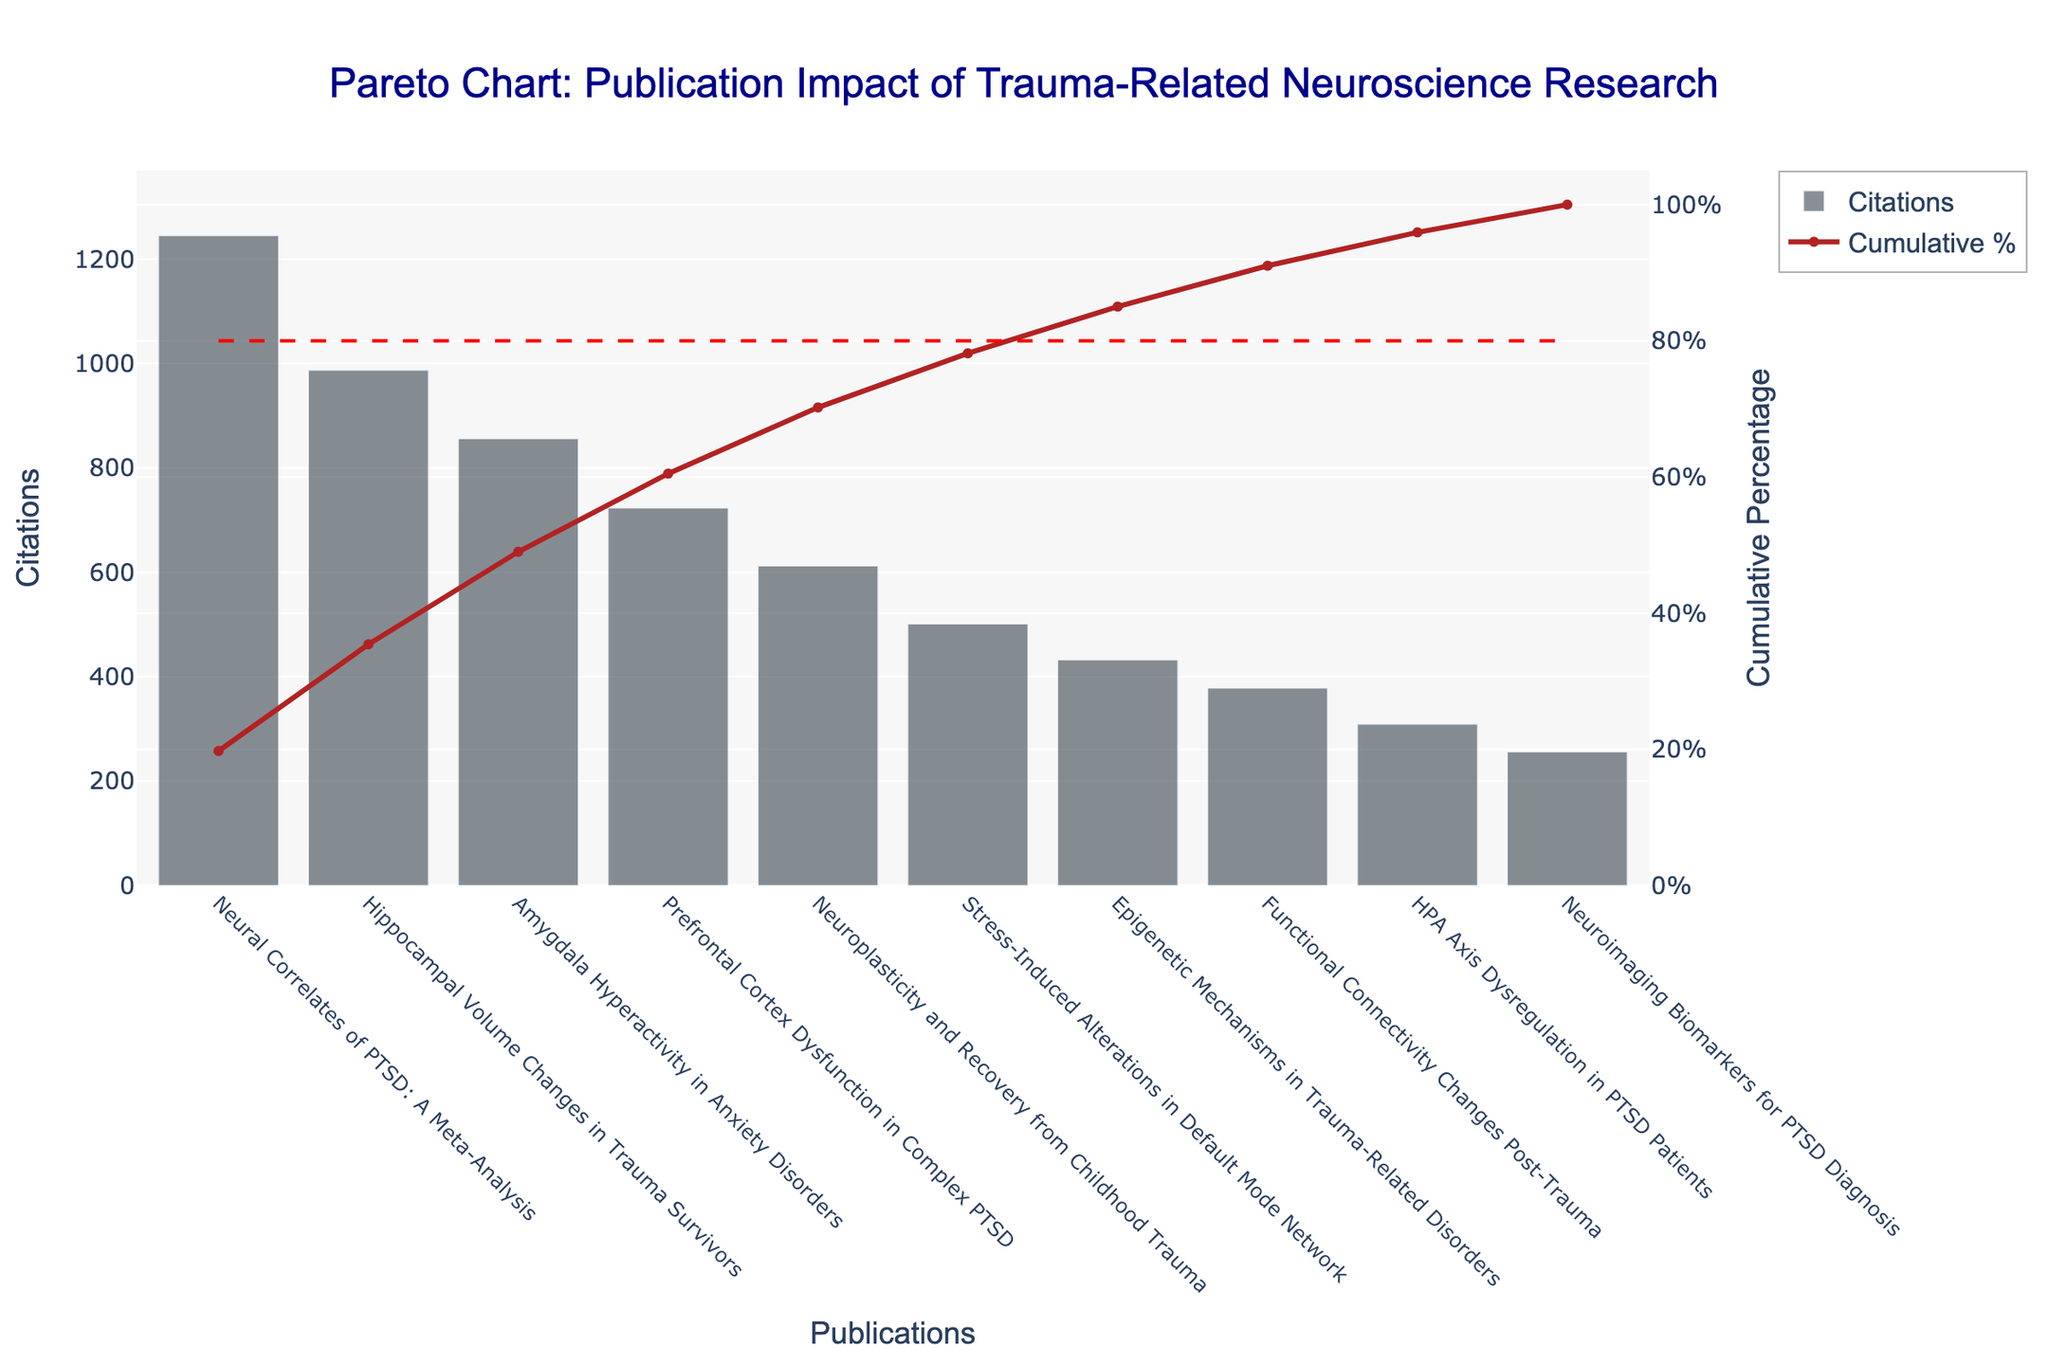What is the title of the figure? The title of the figure is displayed at the top, which reads "Pareto Chart: Publication Impact of Trauma-Related Neuroscience Research".
Answer: Pareto Chart: Publication Impact of Trauma-Related Neuroscience Research Which publication has the highest citation count? The bar with the highest value represents the publication with the most citations. The bar corresponding to "Neural Correlates of PTSD: A Meta-Analysis" has the highest height.
Answer: Neural Correlates of PTSD: A Meta-Analysis What is the total citation count summed up from all publications? The total citation count is the sum of all the individual citation counts listed. Add them: 1245 + 987 + 856 + 723 + 612 + 501 + 432 + 378 + 309 + 256 = 6299.
Answer: 6299 What is the cumulative percentage for "Hippocampal Volume Changes in Trauma Survivors"? Cumulative percentage for a publication is found by moving along the red line. For "Hippocampal Volume Changes in Trauma Survivors" (second publication), the cumulative percentage is around 35-40%.
Answer: Around 35-40% Which publication contributes to crossing the cumulative 80% line? Look for the point where the red cumulative percentage line crosses the 80% horizontal mark. The publication is "Prefrontal Cortex Dysfunction in Complex PTSD".
Answer: Prefrontal Cortex Dysfunction in Complex PTSD How many publications are required to reach approximately 50% cumulative percentage? To determine this, examine where the red cumulative percentage line crosses the 50% mark. This intersection occurs between the third and fourth publication.
Answer: 3 or 4 publications By how much does the citation count of "Amygdala Hyperactivity in Anxiety Disorders" exceed that of "Neuroimaging Biomarkers for PTSD Diagnosis"? By looking at the bar heights, "Amygdala Hyperactivity in Anxiety Disorders" has 856 citations, and "Neuroimaging Biomarkers for PTSD Diagnosis" has 256. The difference is 856 - 256 = 600.
Answer: 600 Which two publications have the smallest difference in citation count? By comparing the bar heights, the two publications with the smallest difference are "HPA Axis Dysregulation in PTSD Patients" (309) and "Neuroimaging Biomarkers for PTSD Diagnosis" (256). The difference is 309 - 256 = 53.
Answer: HPA Axis Dysregulation in PTSD Patients and Neuroimaging Biomarkers for PTSD Diagnosis What is the primary visual difference between the two Y-axes of the figure? The left Y-axis represents Citations in a bar format, while the right Y-axis represents Cumulative Percentage as a line. The left axis has an upper limit slightly above 1200, while the right axis goes up to 100%.
Answer: Citations (left, bar) vs. Cumulative Percentage (right, line) Which publication ranks fifth in terms of citation count, and what is its citation value? Rank the publications by citation count. The fifth publication is "Neuroplasticity and Recovery from Childhood Trauma" with 612 citations.
Answer: Neuroplasticity and Recovery from Childhood Trauma, 612 